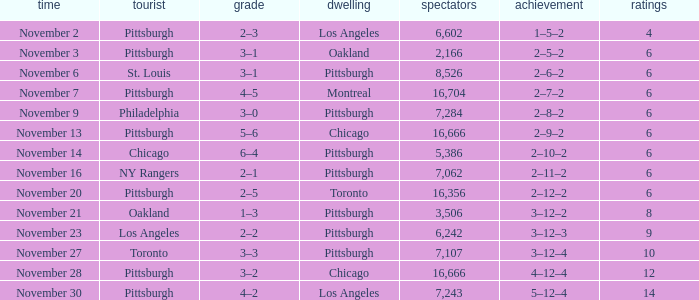What is the sum of the points of the game with philadelphia as the visitor and an attendance greater than 7,284? None. 